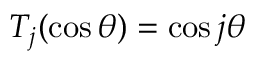<formula> <loc_0><loc_0><loc_500><loc_500>T _ { j } ( \cos \theta ) = \cos j \theta</formula> 